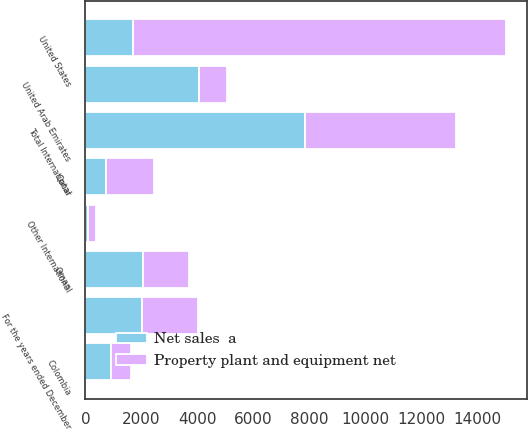Convert chart to OTSL. <chart><loc_0><loc_0><loc_500><loc_500><stacked_bar_chart><ecel><fcel>For the years ended December<fcel>United States<fcel>Qatar<fcel>Oman<fcel>United Arab Emirates<fcel>Colombia<fcel>Other International<fcel>Total International<nl><fcel>Property plant and equipment net<fcel>2018<fcel>13351<fcel>1701<fcel>1667<fcel>1021<fcel>715<fcel>299<fcel>5403<nl><fcel>Net sales  a<fcel>2018<fcel>1701<fcel>741<fcel>2048<fcel>4051<fcel>927<fcel>76<fcel>7843<nl></chart> 